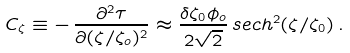<formula> <loc_0><loc_0><loc_500><loc_500>C _ { \zeta } \equiv - \, \frac { \partial ^ { 2 } \tau } { \partial ( \zeta / \zeta _ { o } ) ^ { 2 } } \approx \frac { \delta \zeta _ { 0 } \phi _ { o } } { 2 \sqrt { 2 } } \, s e c h ^ { 2 } ( \zeta / \zeta _ { 0 } ) \, .</formula> 